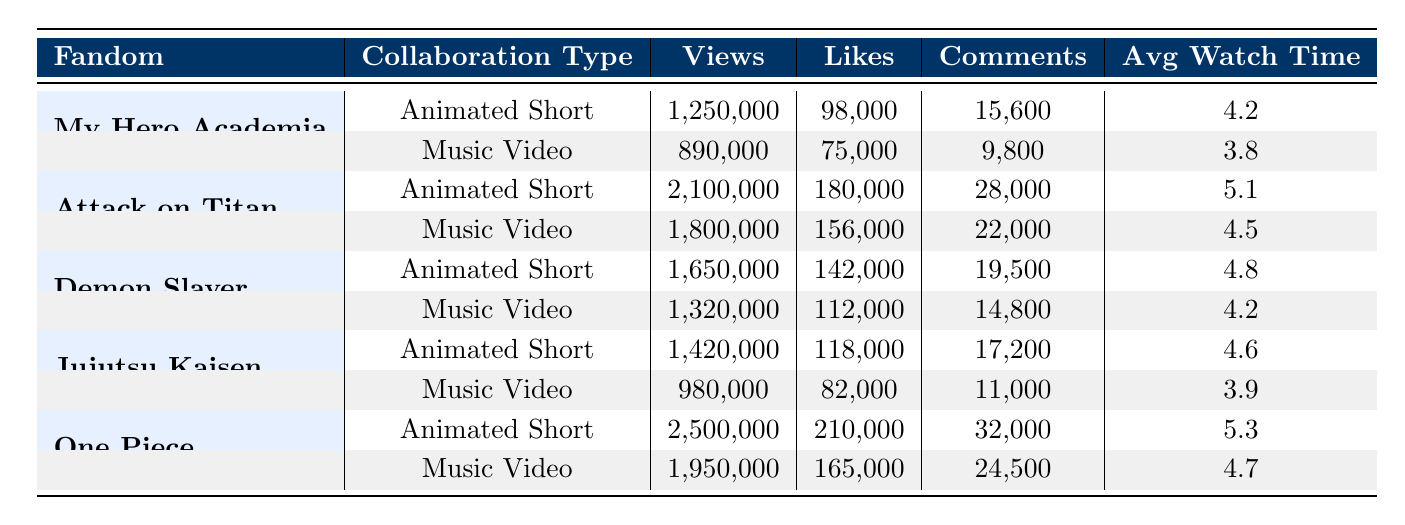What is the total number of views for all Animated Shorts? To find the total views for Animated Shorts, I will sum the views from each row labeled as "Animated Short." From the table: My Hero Academia (1,250,000) + Attack on Titan (2,100,000) + Demon Slayer (1,650,000) + Jujutsu Kaisen (1,420,000) + One Piece (2,500,000) = 8,920,000.
Answer: 8,920,000 Which fandom has the highest average watch time for Music Videos? I will check the Avg Watch Time for each Music Video. The values are: My Hero Academia (3.8), Attack on Titan (4.5), Demon Slayer (4.2), Jujutsu Kaisen (3.9), and One Piece (4.7). The highest value is for One Piece (4.7).
Answer: One Piece Did Jujutsu Kaisen's Animated Short receive more likes than its Music Video? From the table, Jujutsu Kaisen's Animated Short has 118,000 likes, while the Music Video has 82,000 likes. Since 118,000 is greater than 82,000, the Animated Short received more likes.
Answer: Yes What is the difference in views between the highest and lowest viewed Music Videos? I will identify the views for each Music Video: My Hero Academia (890,000), Attack on Titan (1,800,000), Demon Slayer (1,320,000), Jujutsu Kaisen (980,000), and One Piece (1,950,000). The highest is Attack on Titan (1,800,000) and the lowest is My Hero Academia (890,000). The difference is 1,800,000 - 890,000 = 910,000.
Answer: 910,000 How many total shares did the Music Videos receive across all fandoms? I will sum the shares for all Music Videos. The shares are: My Hero Academia (18,000) + Attack on Titan (48,000) + Demon Slayer (35,000) + Jujutsu Kaisen (25,000) + One Piece (52,000) = 178,000 total shares.
Answer: 178,000 